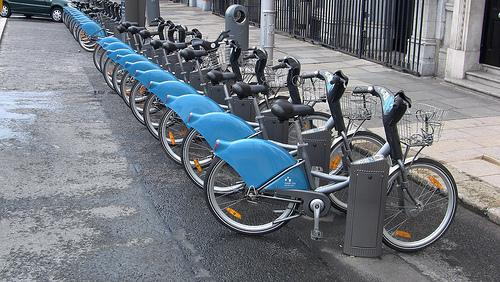Mention the details about the steps and fence in the image. There are steps by a building with a fence beside it, but no further information is provided about their appearance or material. What does the data suggest about the cleanliness and color of the pavement? The pavement is clean according to the data, but there is no information about its color. Give a brief description of the image focusing on the road and pavement. The image shows a clean and grey-colored road with a sidewalk and a pavement nearby. Briefly describe the condition of the road and its surroundings based on the image data. The road is a clean, grey, and tarmacked surface with a pavement and a sidewalk nearby, bicycles parked beside it, and a car close to the bicycles. Describe the scene involving bicycles in the image. There are several bicycles in the image, with the front wheels and pedals being prominently visible. The bicycles are made of metal and are parked by the road. Based on the data, identify any object on a bicycle that is blue in color. There is a blue part on one of the bicycles, but the provided data does not specify which part it is. List objects in the image that can be counted, and provide the number of objects for each category. Bicycles: 9, Wheels on bicycles: 10, Steps near the building: 1, Fences near the building: 1. What is the main color of the road? Mention any related adjectives. The road is mainly grey in color and appears clean and probably tarmacked. Can you identify from the data if there is a car in the image? Provide the color of the car and its wheels. There is a green car in the image with visible wheels, which may be parked near the bicycles. 